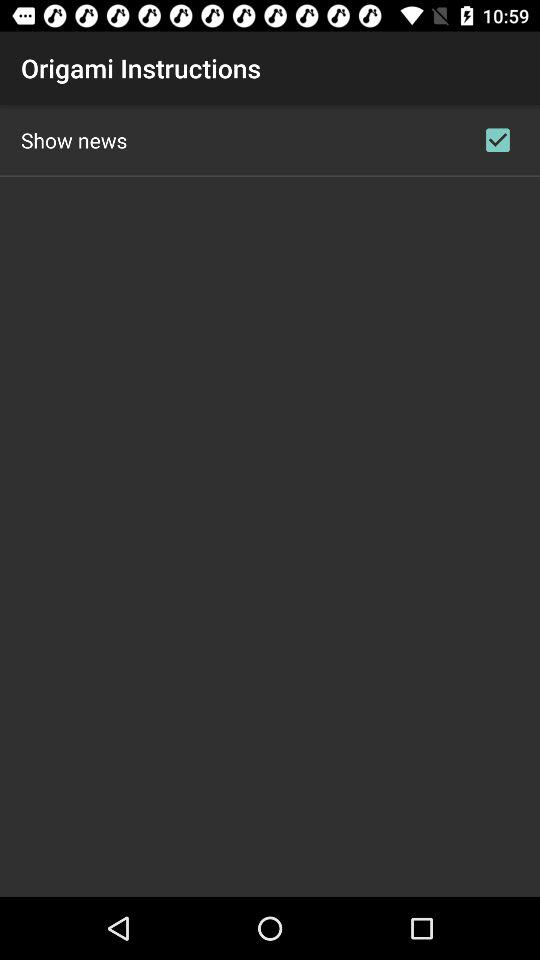What is the name of the page? The name of the page is "Origami Instructions". 